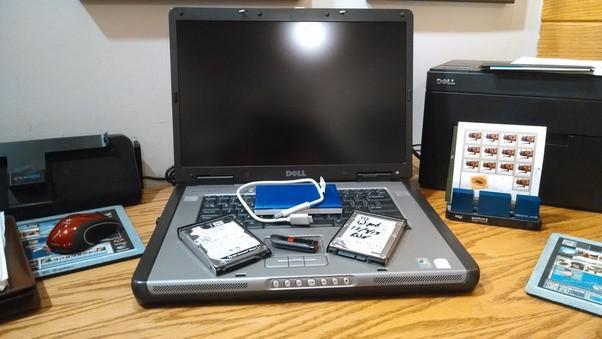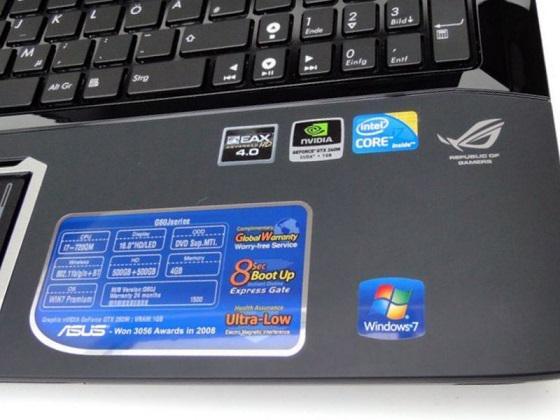The first image is the image on the left, the second image is the image on the right. Considering the images on both sides, is "At least one image contains a single laptop." valid? Answer yes or no. Yes. The first image is the image on the left, the second image is the image on the right. Considering the images on both sides, is "An image shows a row of at least three open laptops, with screens angled facing rightward." valid? Answer yes or no. No. 